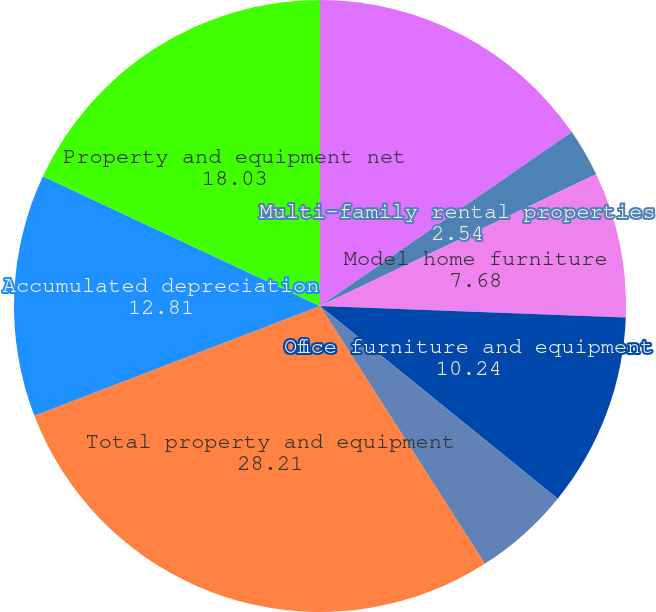<chart> <loc_0><loc_0><loc_500><loc_500><pie_chart><fcel>Buildings and improvements (1)<fcel>Multi-family rental properties<fcel>Model home furniture<fcel>Office furniture and equipment<fcel>Land (1) (2)<fcel>Total property and equipment<fcel>Accumulated depreciation<fcel>Property and equipment net<nl><fcel>15.38%<fcel>2.54%<fcel>7.68%<fcel>10.24%<fcel>5.11%<fcel>28.21%<fcel>12.81%<fcel>18.03%<nl></chart> 